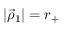Convert formula to latex. <formula><loc_0><loc_0><loc_500><loc_500>| \vec { \rho } _ { 1 } | = r _ { + }</formula> 